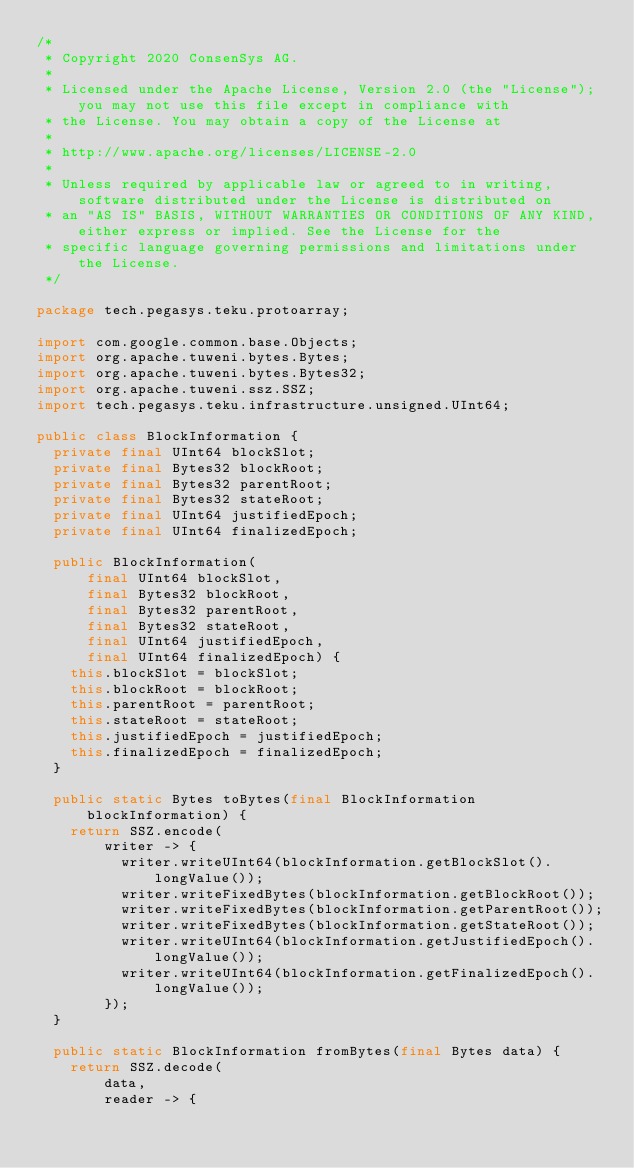<code> <loc_0><loc_0><loc_500><loc_500><_Java_>/*
 * Copyright 2020 ConsenSys AG.
 *
 * Licensed under the Apache License, Version 2.0 (the "License"); you may not use this file except in compliance with
 * the License. You may obtain a copy of the License at
 *
 * http://www.apache.org/licenses/LICENSE-2.0
 *
 * Unless required by applicable law or agreed to in writing, software distributed under the License is distributed on
 * an "AS IS" BASIS, WITHOUT WARRANTIES OR CONDITIONS OF ANY KIND, either express or implied. See the License for the
 * specific language governing permissions and limitations under the License.
 */

package tech.pegasys.teku.protoarray;

import com.google.common.base.Objects;
import org.apache.tuweni.bytes.Bytes;
import org.apache.tuweni.bytes.Bytes32;
import org.apache.tuweni.ssz.SSZ;
import tech.pegasys.teku.infrastructure.unsigned.UInt64;

public class BlockInformation {
  private final UInt64 blockSlot;
  private final Bytes32 blockRoot;
  private final Bytes32 parentRoot;
  private final Bytes32 stateRoot;
  private final UInt64 justifiedEpoch;
  private final UInt64 finalizedEpoch;

  public BlockInformation(
      final UInt64 blockSlot,
      final Bytes32 blockRoot,
      final Bytes32 parentRoot,
      final Bytes32 stateRoot,
      final UInt64 justifiedEpoch,
      final UInt64 finalizedEpoch) {
    this.blockSlot = blockSlot;
    this.blockRoot = blockRoot;
    this.parentRoot = parentRoot;
    this.stateRoot = stateRoot;
    this.justifiedEpoch = justifiedEpoch;
    this.finalizedEpoch = finalizedEpoch;
  }

  public static Bytes toBytes(final BlockInformation blockInformation) {
    return SSZ.encode(
        writer -> {
          writer.writeUInt64(blockInformation.getBlockSlot().longValue());
          writer.writeFixedBytes(blockInformation.getBlockRoot());
          writer.writeFixedBytes(blockInformation.getParentRoot());
          writer.writeFixedBytes(blockInformation.getStateRoot());
          writer.writeUInt64(blockInformation.getJustifiedEpoch().longValue());
          writer.writeUInt64(blockInformation.getFinalizedEpoch().longValue());
        });
  }

  public static BlockInformation fromBytes(final Bytes data) {
    return SSZ.decode(
        data,
        reader -> {</code> 